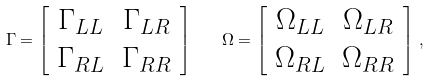Convert formula to latex. <formula><loc_0><loc_0><loc_500><loc_500>\Gamma = \left [ \begin{array} { c c } \Gamma _ { L L } & \Gamma _ { L R } \\ \Gamma _ { R L } & \Gamma _ { R R } \end{array} \right ] \quad \Omega = \left [ \begin{array} { c c } \Omega _ { L L } & \Omega _ { L R } \\ \Omega _ { R L } & \Omega _ { R R } \end{array} \right ] \, ,</formula> 